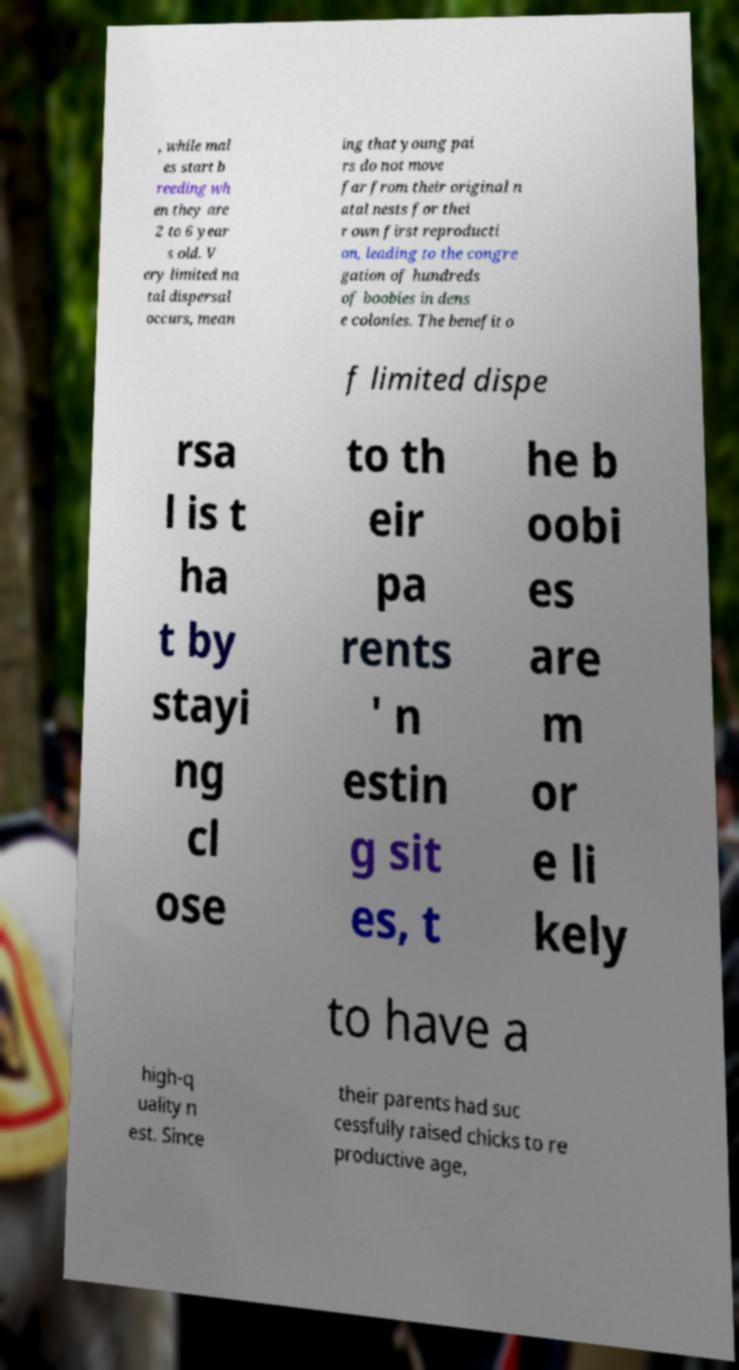Could you assist in decoding the text presented in this image and type it out clearly? , while mal es start b reeding wh en they are 2 to 6 year s old. V ery limited na tal dispersal occurs, mean ing that young pai rs do not move far from their original n atal nests for thei r own first reproducti on, leading to the congre gation of hundreds of boobies in dens e colonies. The benefit o f limited dispe rsa l is t ha t by stayi ng cl ose to th eir pa rents ' n estin g sit es, t he b oobi es are m or e li kely to have a high-q uality n est. Since their parents had suc cessfully raised chicks to re productive age, 